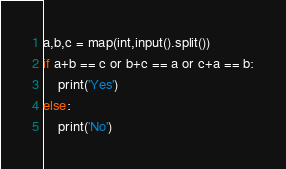Convert code to text. <code><loc_0><loc_0><loc_500><loc_500><_Python_>a,b,c = map(int,input().split())
if a+b == c or b+c == a or c+a == b:
    print('Yes')
else:
    print('No') </code> 